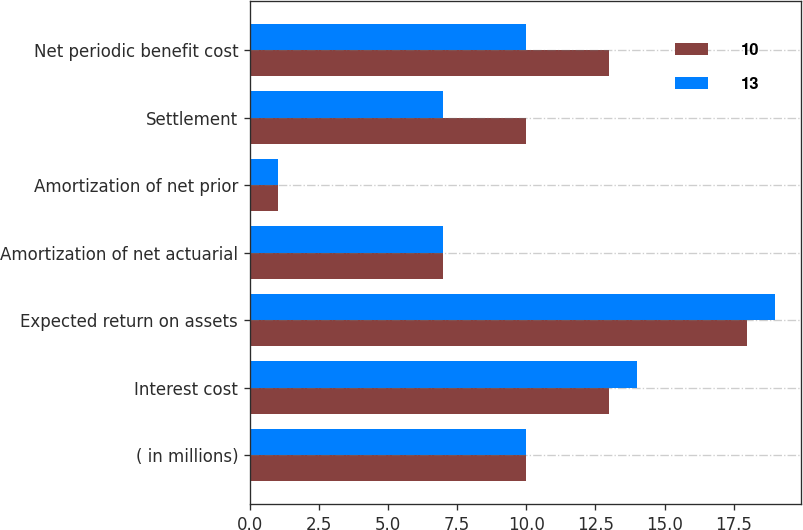<chart> <loc_0><loc_0><loc_500><loc_500><stacked_bar_chart><ecel><fcel>( in millions)<fcel>Interest cost<fcel>Expected return on assets<fcel>Amortization of net actuarial<fcel>Amortization of net prior<fcel>Settlement<fcel>Net periodic benefit cost<nl><fcel>10<fcel>10<fcel>13<fcel>18<fcel>7<fcel>1<fcel>10<fcel>13<nl><fcel>13<fcel>10<fcel>14<fcel>19<fcel>7<fcel>1<fcel>7<fcel>10<nl></chart> 